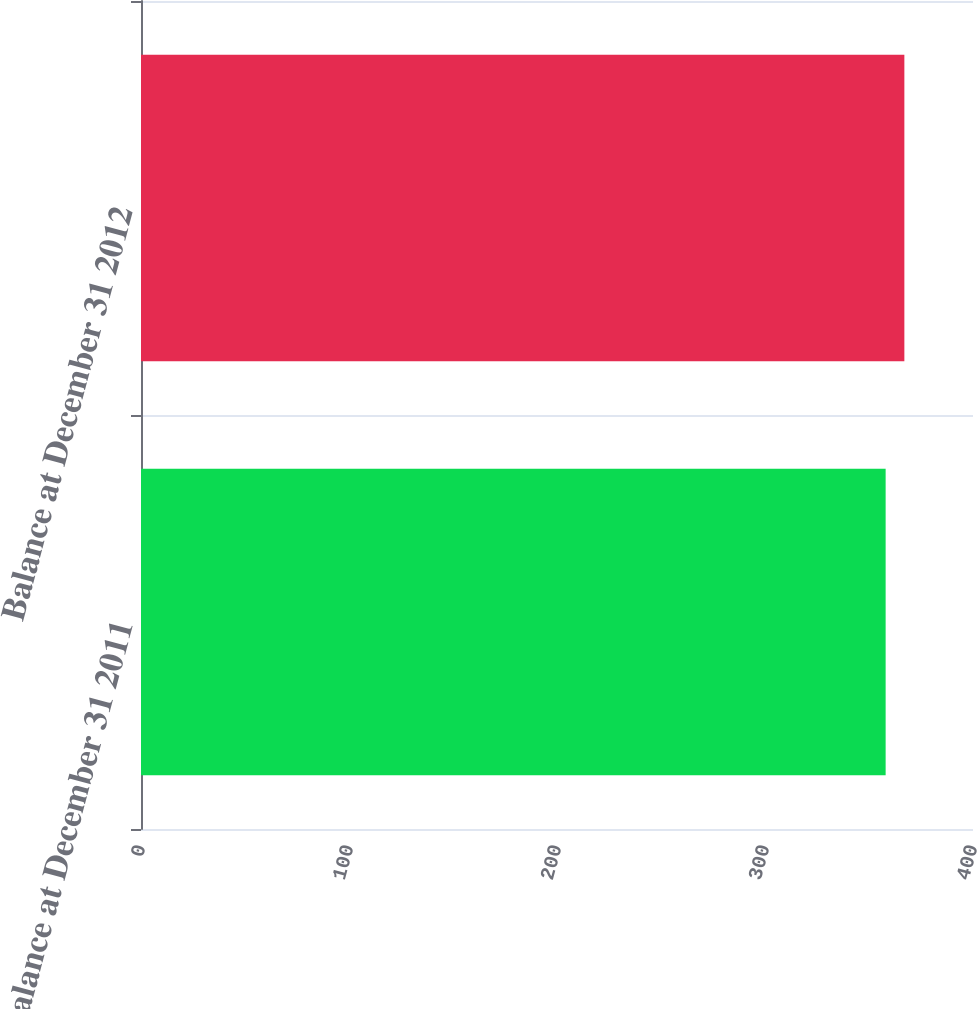<chart> <loc_0><loc_0><loc_500><loc_500><bar_chart><fcel>Balance at December 31 2011<fcel>Balance at December 31 2012<nl><fcel>358<fcel>367<nl></chart> 